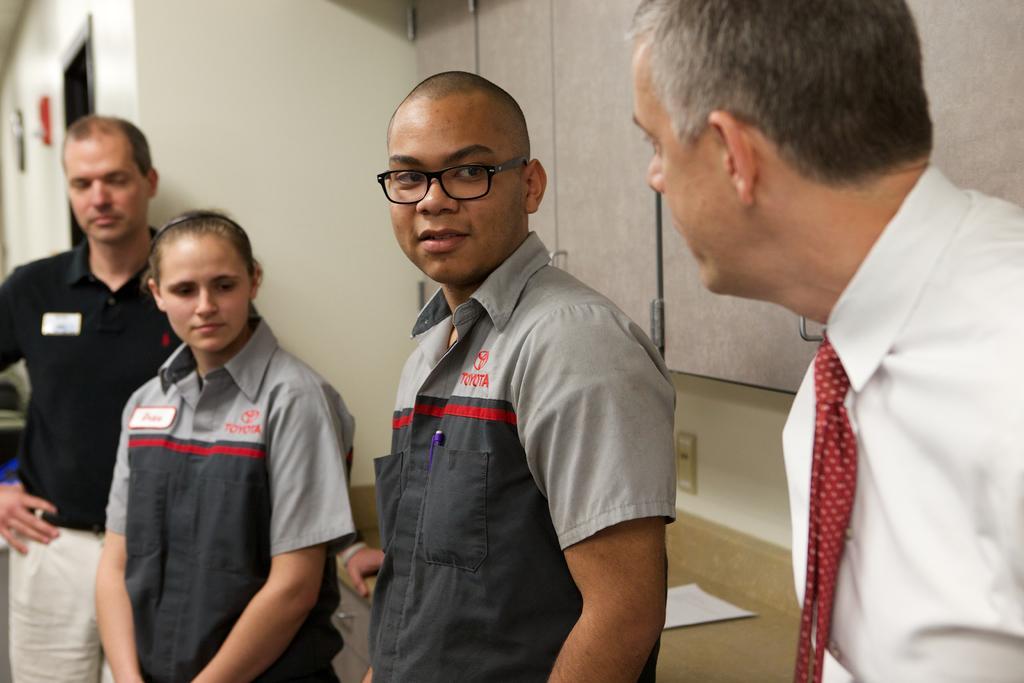Could you give a brief overview of what you see in this image? In this picture we can see 4 people standing and looking at something. 